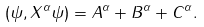Convert formula to latex. <formula><loc_0><loc_0><loc_500><loc_500>( \psi , X ^ { \alpha } \psi ) = A ^ { \alpha } + B ^ { \alpha } + C ^ { \alpha } .</formula> 